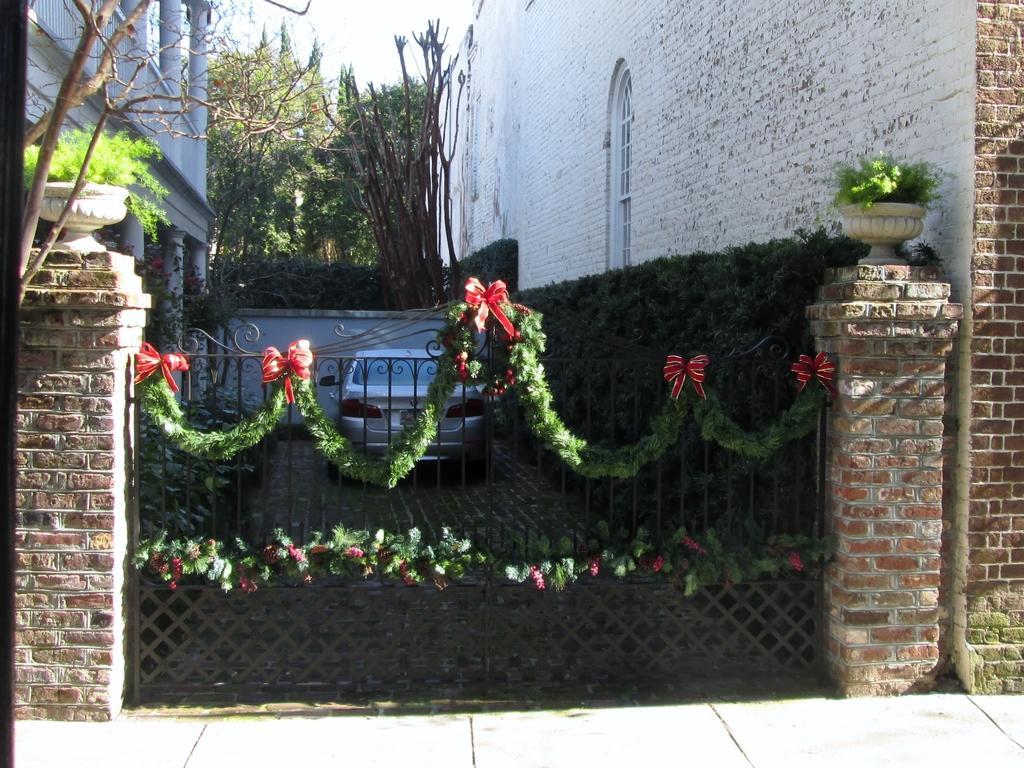Could you give a brief overview of what you see in this image? In the image we can see the buildings made up of brick. Here we can see the gate and a vehicle. We can even see plant pot, trees, footpath and the sky. 